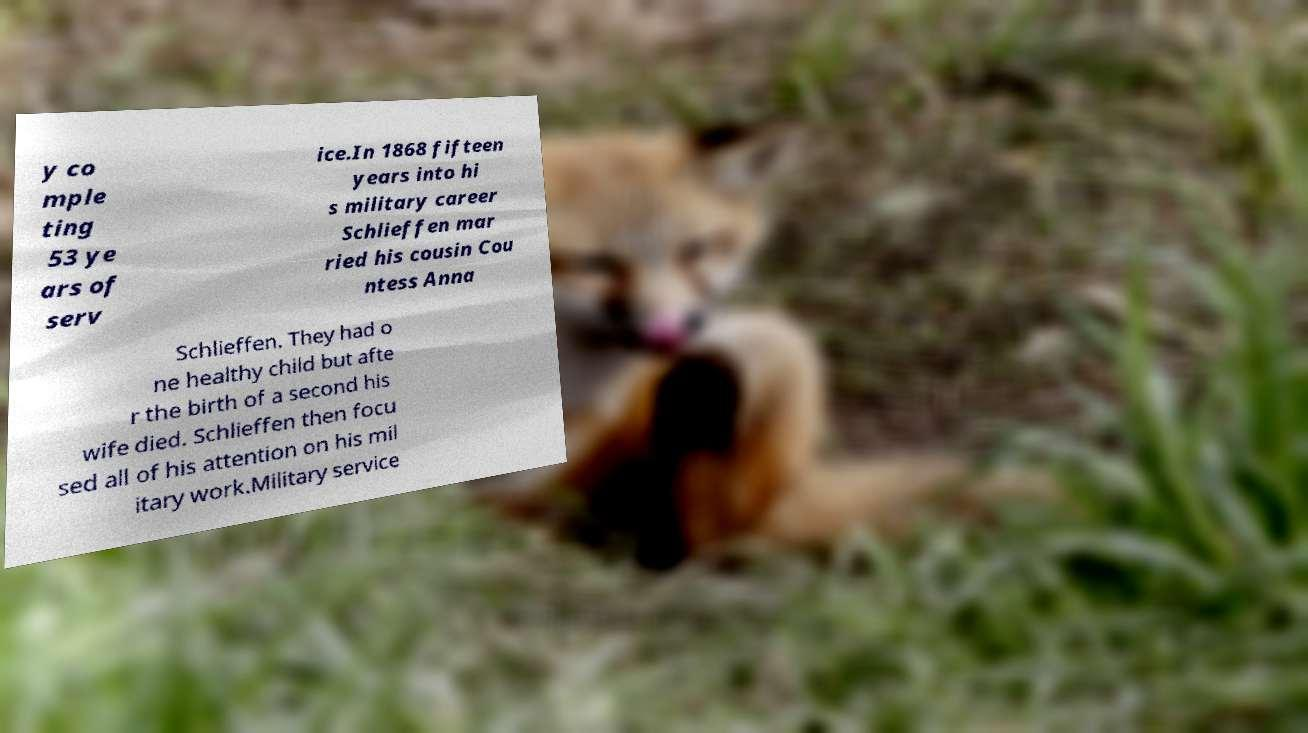Please identify and transcribe the text found in this image. y co mple ting 53 ye ars of serv ice.In 1868 fifteen years into hi s military career Schlieffen mar ried his cousin Cou ntess Anna Schlieffen. They had o ne healthy child but afte r the birth of a second his wife died. Schlieffen then focu sed all of his attention on his mil itary work.Military service 